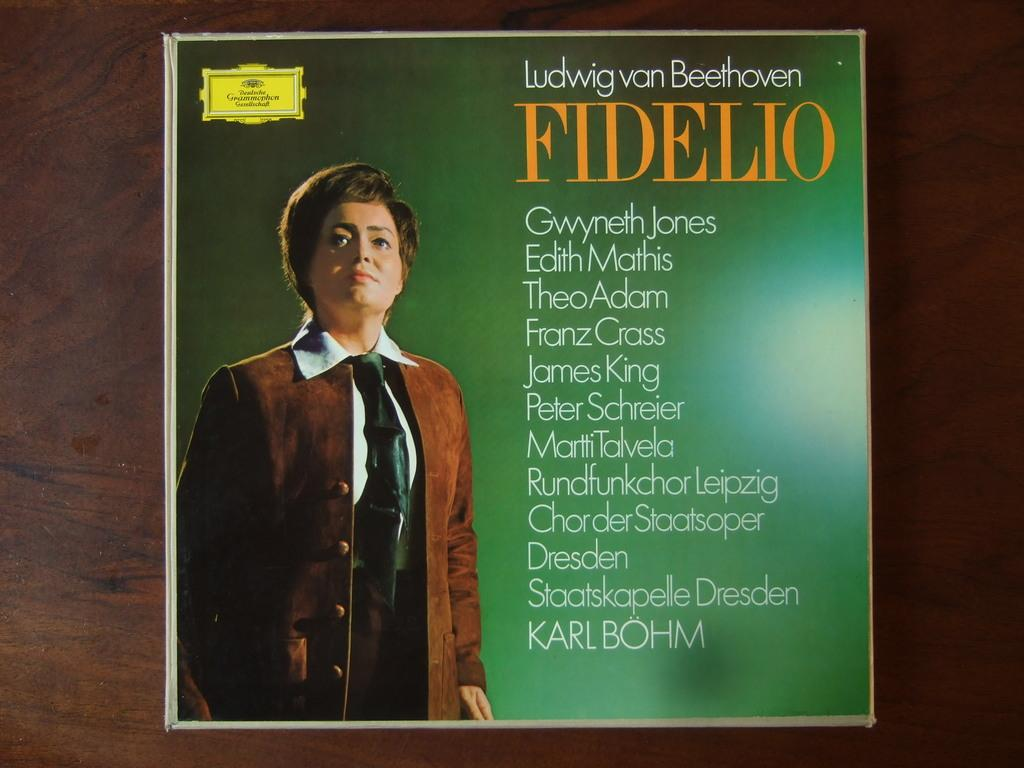<image>
Summarize the visual content of the image. Fidelio features Gwyneth Jones and Edith Mathis among many others. 